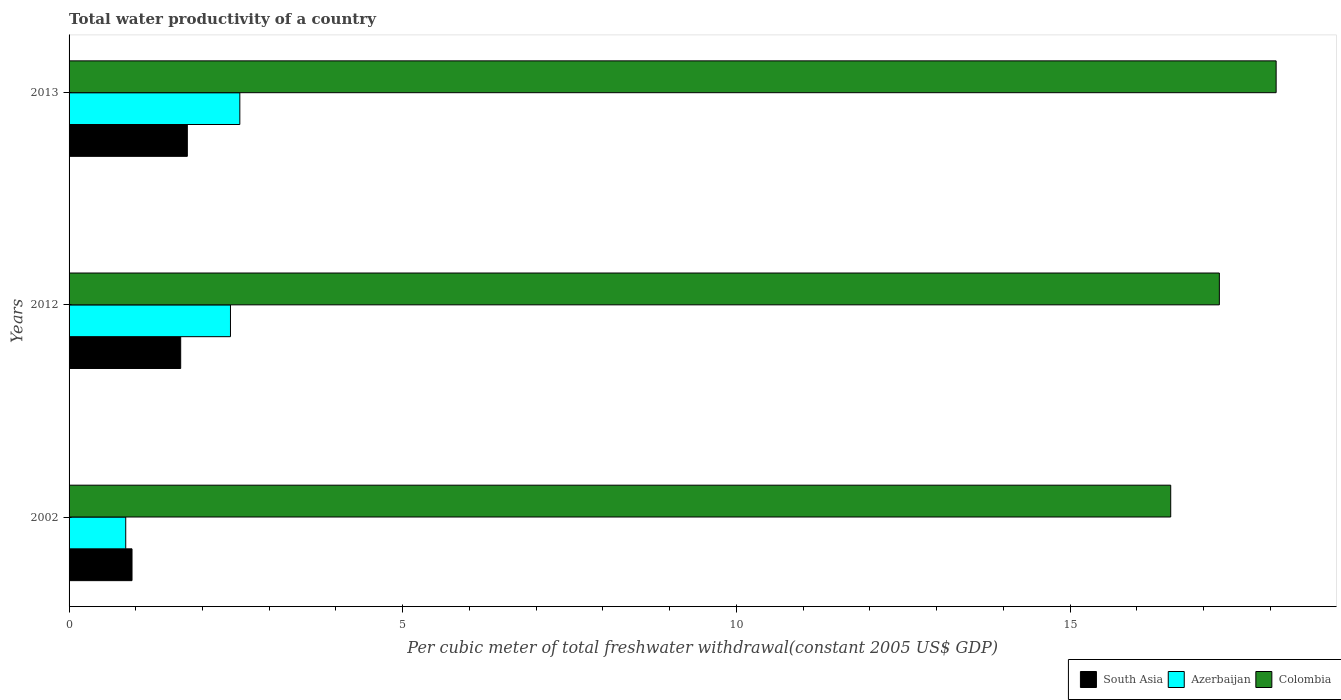How many different coloured bars are there?
Provide a succinct answer. 3. Are the number of bars on each tick of the Y-axis equal?
Ensure brevity in your answer.  Yes. How many bars are there on the 2nd tick from the bottom?
Provide a short and direct response. 3. What is the label of the 3rd group of bars from the top?
Keep it short and to the point. 2002. In how many cases, is the number of bars for a given year not equal to the number of legend labels?
Provide a succinct answer. 0. What is the total water productivity in Colombia in 2012?
Keep it short and to the point. 17.24. Across all years, what is the maximum total water productivity in South Asia?
Provide a short and direct response. 1.77. Across all years, what is the minimum total water productivity in Colombia?
Ensure brevity in your answer.  16.51. In which year was the total water productivity in South Asia minimum?
Provide a short and direct response. 2002. What is the total total water productivity in South Asia in the graph?
Ensure brevity in your answer.  4.39. What is the difference between the total water productivity in South Asia in 2012 and that in 2013?
Your answer should be compact. -0.1. What is the difference between the total water productivity in Azerbaijan in 2013 and the total water productivity in South Asia in 2002?
Your response must be concise. 1.62. What is the average total water productivity in South Asia per year?
Offer a very short reply. 1.46. In the year 2012, what is the difference between the total water productivity in Azerbaijan and total water productivity in South Asia?
Give a very brief answer. 0.75. In how many years, is the total water productivity in Colombia greater than 13 US$?
Ensure brevity in your answer.  3. What is the ratio of the total water productivity in Azerbaijan in 2002 to that in 2012?
Offer a terse response. 0.35. What is the difference between the highest and the second highest total water productivity in South Asia?
Your response must be concise. 0.1. What is the difference between the highest and the lowest total water productivity in Azerbaijan?
Provide a short and direct response. 1.71. In how many years, is the total water productivity in South Asia greater than the average total water productivity in South Asia taken over all years?
Offer a very short reply. 2. Is the sum of the total water productivity in South Asia in 2002 and 2012 greater than the maximum total water productivity in Azerbaijan across all years?
Give a very brief answer. Yes. What does the 2nd bar from the bottom in 2013 represents?
Give a very brief answer. Azerbaijan. How many bars are there?
Your response must be concise. 9. Does the graph contain any zero values?
Make the answer very short. No. Does the graph contain grids?
Offer a very short reply. No. Where does the legend appear in the graph?
Offer a very short reply. Bottom right. What is the title of the graph?
Provide a short and direct response. Total water productivity of a country. Does "Ukraine" appear as one of the legend labels in the graph?
Give a very brief answer. No. What is the label or title of the X-axis?
Ensure brevity in your answer.  Per cubic meter of total freshwater withdrawal(constant 2005 US$ GDP). What is the label or title of the Y-axis?
Offer a very short reply. Years. What is the Per cubic meter of total freshwater withdrawal(constant 2005 US$ GDP) of South Asia in 2002?
Offer a terse response. 0.94. What is the Per cubic meter of total freshwater withdrawal(constant 2005 US$ GDP) in Azerbaijan in 2002?
Keep it short and to the point. 0.85. What is the Per cubic meter of total freshwater withdrawal(constant 2005 US$ GDP) of Colombia in 2002?
Provide a succinct answer. 16.51. What is the Per cubic meter of total freshwater withdrawal(constant 2005 US$ GDP) of South Asia in 2012?
Provide a short and direct response. 1.67. What is the Per cubic meter of total freshwater withdrawal(constant 2005 US$ GDP) in Azerbaijan in 2012?
Ensure brevity in your answer.  2.42. What is the Per cubic meter of total freshwater withdrawal(constant 2005 US$ GDP) of Colombia in 2012?
Ensure brevity in your answer.  17.24. What is the Per cubic meter of total freshwater withdrawal(constant 2005 US$ GDP) of South Asia in 2013?
Make the answer very short. 1.77. What is the Per cubic meter of total freshwater withdrawal(constant 2005 US$ GDP) of Azerbaijan in 2013?
Make the answer very short. 2.56. What is the Per cubic meter of total freshwater withdrawal(constant 2005 US$ GDP) in Colombia in 2013?
Offer a very short reply. 18.09. Across all years, what is the maximum Per cubic meter of total freshwater withdrawal(constant 2005 US$ GDP) of South Asia?
Give a very brief answer. 1.77. Across all years, what is the maximum Per cubic meter of total freshwater withdrawal(constant 2005 US$ GDP) in Azerbaijan?
Your response must be concise. 2.56. Across all years, what is the maximum Per cubic meter of total freshwater withdrawal(constant 2005 US$ GDP) of Colombia?
Provide a short and direct response. 18.09. Across all years, what is the minimum Per cubic meter of total freshwater withdrawal(constant 2005 US$ GDP) in South Asia?
Your response must be concise. 0.94. Across all years, what is the minimum Per cubic meter of total freshwater withdrawal(constant 2005 US$ GDP) of Azerbaijan?
Offer a very short reply. 0.85. Across all years, what is the minimum Per cubic meter of total freshwater withdrawal(constant 2005 US$ GDP) in Colombia?
Provide a succinct answer. 16.51. What is the total Per cubic meter of total freshwater withdrawal(constant 2005 US$ GDP) of South Asia in the graph?
Provide a short and direct response. 4.39. What is the total Per cubic meter of total freshwater withdrawal(constant 2005 US$ GDP) of Azerbaijan in the graph?
Offer a terse response. 5.83. What is the total Per cubic meter of total freshwater withdrawal(constant 2005 US$ GDP) of Colombia in the graph?
Provide a succinct answer. 51.84. What is the difference between the Per cubic meter of total freshwater withdrawal(constant 2005 US$ GDP) of South Asia in 2002 and that in 2012?
Your answer should be compact. -0.73. What is the difference between the Per cubic meter of total freshwater withdrawal(constant 2005 US$ GDP) of Azerbaijan in 2002 and that in 2012?
Give a very brief answer. -1.57. What is the difference between the Per cubic meter of total freshwater withdrawal(constant 2005 US$ GDP) of Colombia in 2002 and that in 2012?
Your answer should be very brief. -0.73. What is the difference between the Per cubic meter of total freshwater withdrawal(constant 2005 US$ GDP) in South Asia in 2002 and that in 2013?
Make the answer very short. -0.83. What is the difference between the Per cubic meter of total freshwater withdrawal(constant 2005 US$ GDP) of Azerbaijan in 2002 and that in 2013?
Your answer should be very brief. -1.71. What is the difference between the Per cubic meter of total freshwater withdrawal(constant 2005 US$ GDP) of Colombia in 2002 and that in 2013?
Give a very brief answer. -1.58. What is the difference between the Per cubic meter of total freshwater withdrawal(constant 2005 US$ GDP) of South Asia in 2012 and that in 2013?
Provide a succinct answer. -0.1. What is the difference between the Per cubic meter of total freshwater withdrawal(constant 2005 US$ GDP) of Azerbaijan in 2012 and that in 2013?
Give a very brief answer. -0.14. What is the difference between the Per cubic meter of total freshwater withdrawal(constant 2005 US$ GDP) in Colombia in 2012 and that in 2013?
Make the answer very short. -0.85. What is the difference between the Per cubic meter of total freshwater withdrawal(constant 2005 US$ GDP) in South Asia in 2002 and the Per cubic meter of total freshwater withdrawal(constant 2005 US$ GDP) in Azerbaijan in 2012?
Your response must be concise. -1.48. What is the difference between the Per cubic meter of total freshwater withdrawal(constant 2005 US$ GDP) of South Asia in 2002 and the Per cubic meter of total freshwater withdrawal(constant 2005 US$ GDP) of Colombia in 2012?
Your response must be concise. -16.29. What is the difference between the Per cubic meter of total freshwater withdrawal(constant 2005 US$ GDP) of Azerbaijan in 2002 and the Per cubic meter of total freshwater withdrawal(constant 2005 US$ GDP) of Colombia in 2012?
Your response must be concise. -16.39. What is the difference between the Per cubic meter of total freshwater withdrawal(constant 2005 US$ GDP) in South Asia in 2002 and the Per cubic meter of total freshwater withdrawal(constant 2005 US$ GDP) in Azerbaijan in 2013?
Offer a terse response. -1.62. What is the difference between the Per cubic meter of total freshwater withdrawal(constant 2005 US$ GDP) of South Asia in 2002 and the Per cubic meter of total freshwater withdrawal(constant 2005 US$ GDP) of Colombia in 2013?
Provide a short and direct response. -17.15. What is the difference between the Per cubic meter of total freshwater withdrawal(constant 2005 US$ GDP) of Azerbaijan in 2002 and the Per cubic meter of total freshwater withdrawal(constant 2005 US$ GDP) of Colombia in 2013?
Offer a very short reply. -17.24. What is the difference between the Per cubic meter of total freshwater withdrawal(constant 2005 US$ GDP) of South Asia in 2012 and the Per cubic meter of total freshwater withdrawal(constant 2005 US$ GDP) of Azerbaijan in 2013?
Make the answer very short. -0.89. What is the difference between the Per cubic meter of total freshwater withdrawal(constant 2005 US$ GDP) of South Asia in 2012 and the Per cubic meter of total freshwater withdrawal(constant 2005 US$ GDP) of Colombia in 2013?
Ensure brevity in your answer.  -16.42. What is the difference between the Per cubic meter of total freshwater withdrawal(constant 2005 US$ GDP) of Azerbaijan in 2012 and the Per cubic meter of total freshwater withdrawal(constant 2005 US$ GDP) of Colombia in 2013?
Provide a succinct answer. -15.67. What is the average Per cubic meter of total freshwater withdrawal(constant 2005 US$ GDP) in South Asia per year?
Give a very brief answer. 1.46. What is the average Per cubic meter of total freshwater withdrawal(constant 2005 US$ GDP) in Azerbaijan per year?
Provide a short and direct response. 1.94. What is the average Per cubic meter of total freshwater withdrawal(constant 2005 US$ GDP) of Colombia per year?
Offer a very short reply. 17.28. In the year 2002, what is the difference between the Per cubic meter of total freshwater withdrawal(constant 2005 US$ GDP) of South Asia and Per cubic meter of total freshwater withdrawal(constant 2005 US$ GDP) of Azerbaijan?
Give a very brief answer. 0.09. In the year 2002, what is the difference between the Per cubic meter of total freshwater withdrawal(constant 2005 US$ GDP) in South Asia and Per cubic meter of total freshwater withdrawal(constant 2005 US$ GDP) in Colombia?
Offer a terse response. -15.57. In the year 2002, what is the difference between the Per cubic meter of total freshwater withdrawal(constant 2005 US$ GDP) of Azerbaijan and Per cubic meter of total freshwater withdrawal(constant 2005 US$ GDP) of Colombia?
Offer a terse response. -15.66. In the year 2012, what is the difference between the Per cubic meter of total freshwater withdrawal(constant 2005 US$ GDP) in South Asia and Per cubic meter of total freshwater withdrawal(constant 2005 US$ GDP) in Azerbaijan?
Ensure brevity in your answer.  -0.75. In the year 2012, what is the difference between the Per cubic meter of total freshwater withdrawal(constant 2005 US$ GDP) of South Asia and Per cubic meter of total freshwater withdrawal(constant 2005 US$ GDP) of Colombia?
Give a very brief answer. -15.57. In the year 2012, what is the difference between the Per cubic meter of total freshwater withdrawal(constant 2005 US$ GDP) in Azerbaijan and Per cubic meter of total freshwater withdrawal(constant 2005 US$ GDP) in Colombia?
Ensure brevity in your answer.  -14.82. In the year 2013, what is the difference between the Per cubic meter of total freshwater withdrawal(constant 2005 US$ GDP) in South Asia and Per cubic meter of total freshwater withdrawal(constant 2005 US$ GDP) in Azerbaijan?
Offer a terse response. -0.79. In the year 2013, what is the difference between the Per cubic meter of total freshwater withdrawal(constant 2005 US$ GDP) in South Asia and Per cubic meter of total freshwater withdrawal(constant 2005 US$ GDP) in Colombia?
Give a very brief answer. -16.32. In the year 2013, what is the difference between the Per cubic meter of total freshwater withdrawal(constant 2005 US$ GDP) in Azerbaijan and Per cubic meter of total freshwater withdrawal(constant 2005 US$ GDP) in Colombia?
Make the answer very short. -15.53. What is the ratio of the Per cubic meter of total freshwater withdrawal(constant 2005 US$ GDP) in South Asia in 2002 to that in 2012?
Offer a very short reply. 0.56. What is the ratio of the Per cubic meter of total freshwater withdrawal(constant 2005 US$ GDP) in Azerbaijan in 2002 to that in 2012?
Offer a very short reply. 0.35. What is the ratio of the Per cubic meter of total freshwater withdrawal(constant 2005 US$ GDP) of Colombia in 2002 to that in 2012?
Make the answer very short. 0.96. What is the ratio of the Per cubic meter of total freshwater withdrawal(constant 2005 US$ GDP) of South Asia in 2002 to that in 2013?
Offer a very short reply. 0.53. What is the ratio of the Per cubic meter of total freshwater withdrawal(constant 2005 US$ GDP) of Azerbaijan in 2002 to that in 2013?
Provide a succinct answer. 0.33. What is the ratio of the Per cubic meter of total freshwater withdrawal(constant 2005 US$ GDP) in Colombia in 2002 to that in 2013?
Provide a succinct answer. 0.91. What is the ratio of the Per cubic meter of total freshwater withdrawal(constant 2005 US$ GDP) in South Asia in 2012 to that in 2013?
Provide a succinct answer. 0.94. What is the ratio of the Per cubic meter of total freshwater withdrawal(constant 2005 US$ GDP) in Azerbaijan in 2012 to that in 2013?
Your answer should be very brief. 0.95. What is the ratio of the Per cubic meter of total freshwater withdrawal(constant 2005 US$ GDP) of Colombia in 2012 to that in 2013?
Your answer should be compact. 0.95. What is the difference between the highest and the second highest Per cubic meter of total freshwater withdrawal(constant 2005 US$ GDP) of South Asia?
Your answer should be very brief. 0.1. What is the difference between the highest and the second highest Per cubic meter of total freshwater withdrawal(constant 2005 US$ GDP) in Azerbaijan?
Make the answer very short. 0.14. What is the difference between the highest and the second highest Per cubic meter of total freshwater withdrawal(constant 2005 US$ GDP) in Colombia?
Ensure brevity in your answer.  0.85. What is the difference between the highest and the lowest Per cubic meter of total freshwater withdrawal(constant 2005 US$ GDP) of South Asia?
Offer a very short reply. 0.83. What is the difference between the highest and the lowest Per cubic meter of total freshwater withdrawal(constant 2005 US$ GDP) of Azerbaijan?
Offer a very short reply. 1.71. What is the difference between the highest and the lowest Per cubic meter of total freshwater withdrawal(constant 2005 US$ GDP) of Colombia?
Your response must be concise. 1.58. 